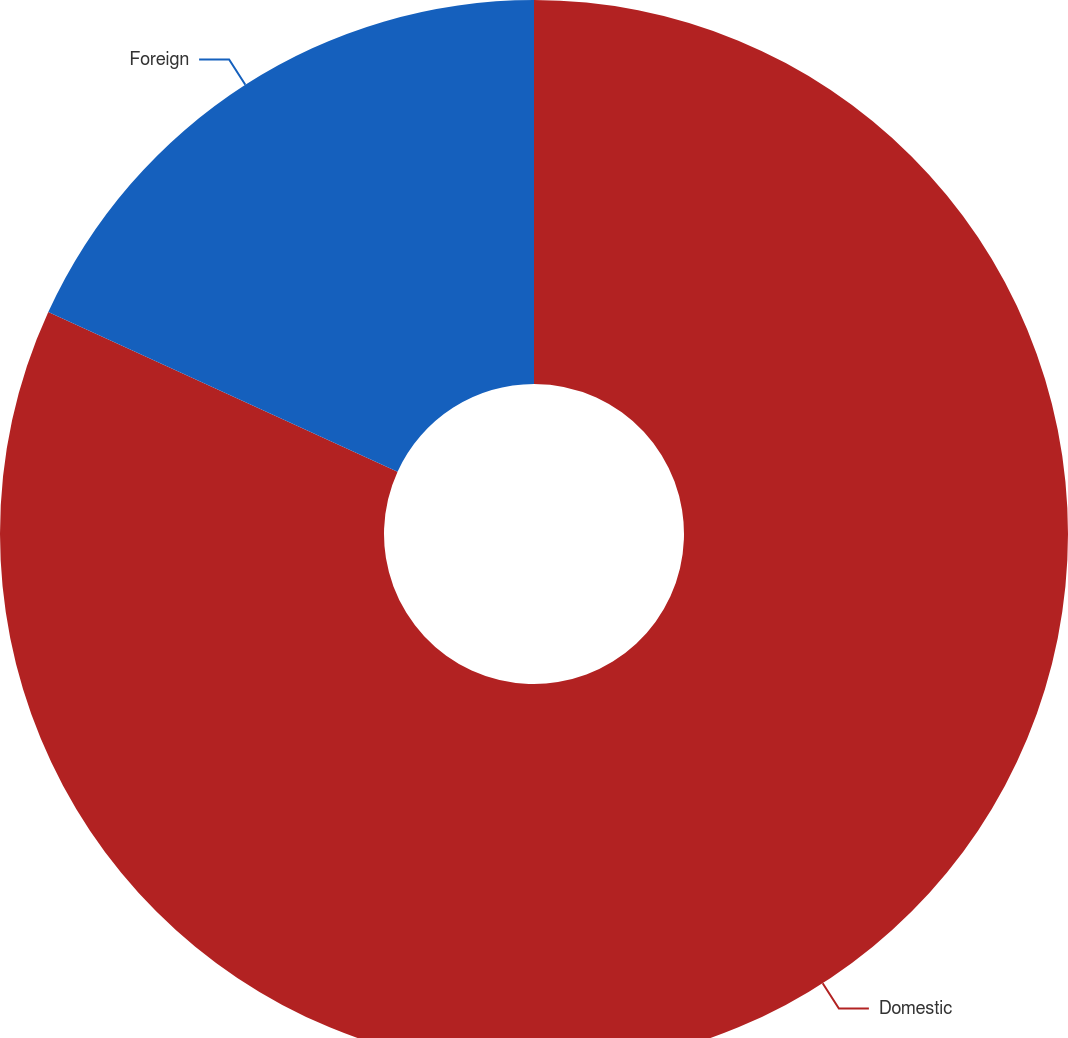Convert chart to OTSL. <chart><loc_0><loc_0><loc_500><loc_500><pie_chart><fcel>Domestic<fcel>Foreign<nl><fcel>81.82%<fcel>18.18%<nl></chart> 